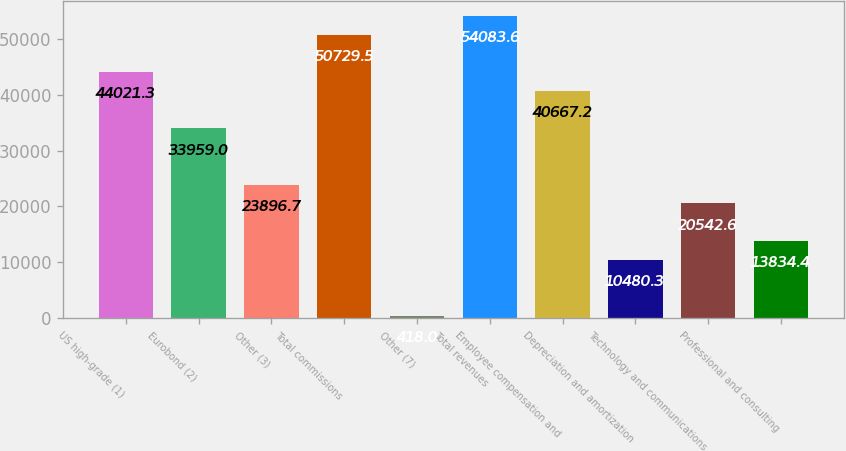Convert chart to OTSL. <chart><loc_0><loc_0><loc_500><loc_500><bar_chart><fcel>US high-grade (1)<fcel>Eurobond (2)<fcel>Other (3)<fcel>Total commissions<fcel>Other (7)<fcel>Total revenues<fcel>Employee compensation and<fcel>Depreciation and amortization<fcel>Technology and communications<fcel>Professional and consulting<nl><fcel>44021.3<fcel>33959<fcel>23896.7<fcel>50729.5<fcel>418<fcel>54083.6<fcel>40667.2<fcel>10480.3<fcel>20542.6<fcel>13834.4<nl></chart> 